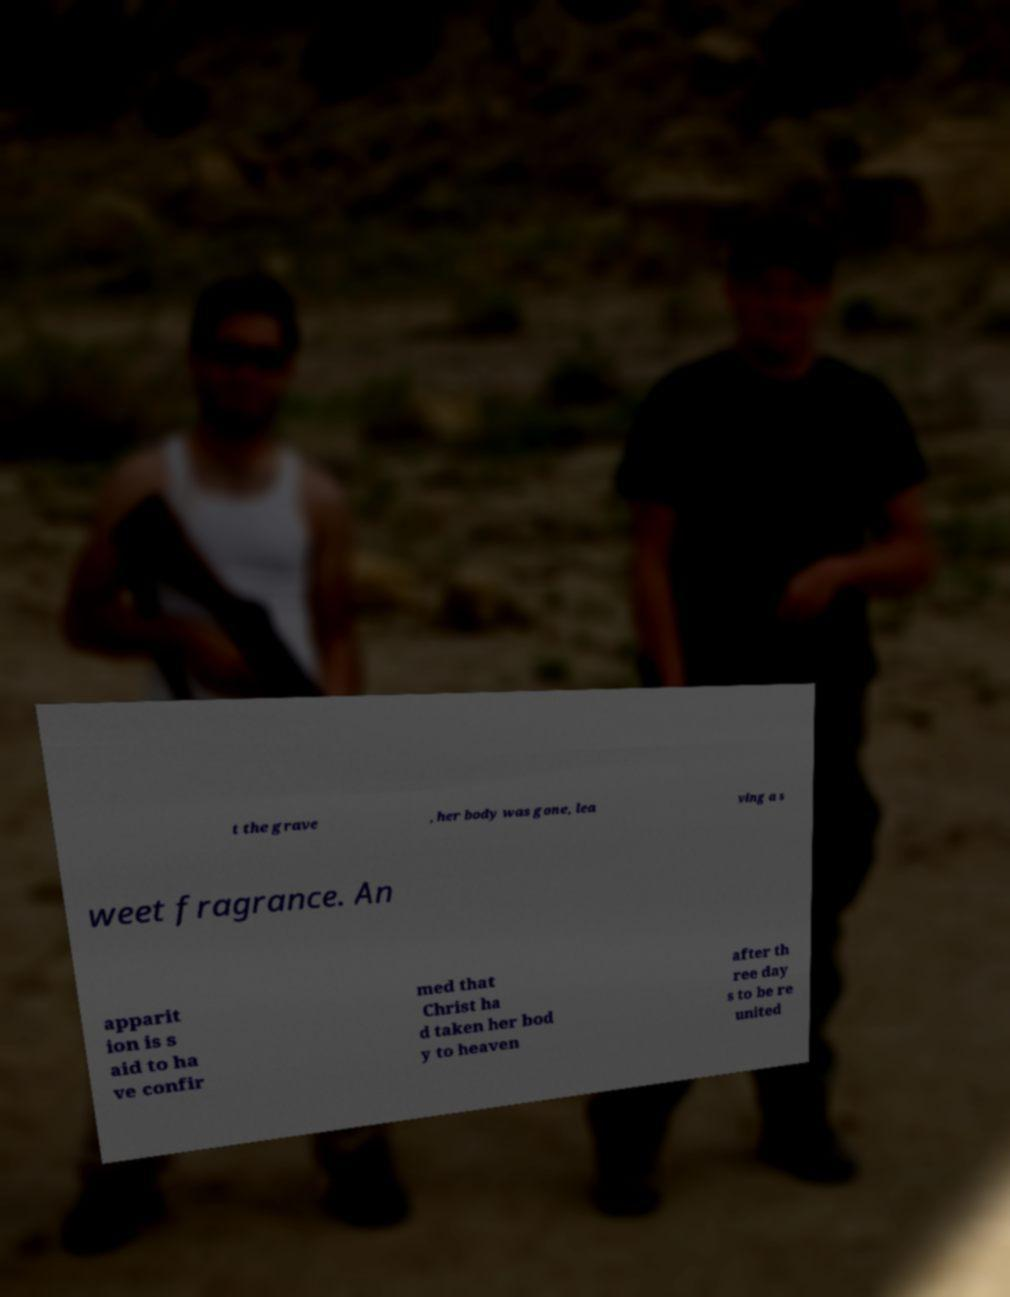Could you extract and type out the text from this image? t the grave , her body was gone, lea ving a s weet fragrance. An apparit ion is s aid to ha ve confir med that Christ ha d taken her bod y to heaven after th ree day s to be re united 